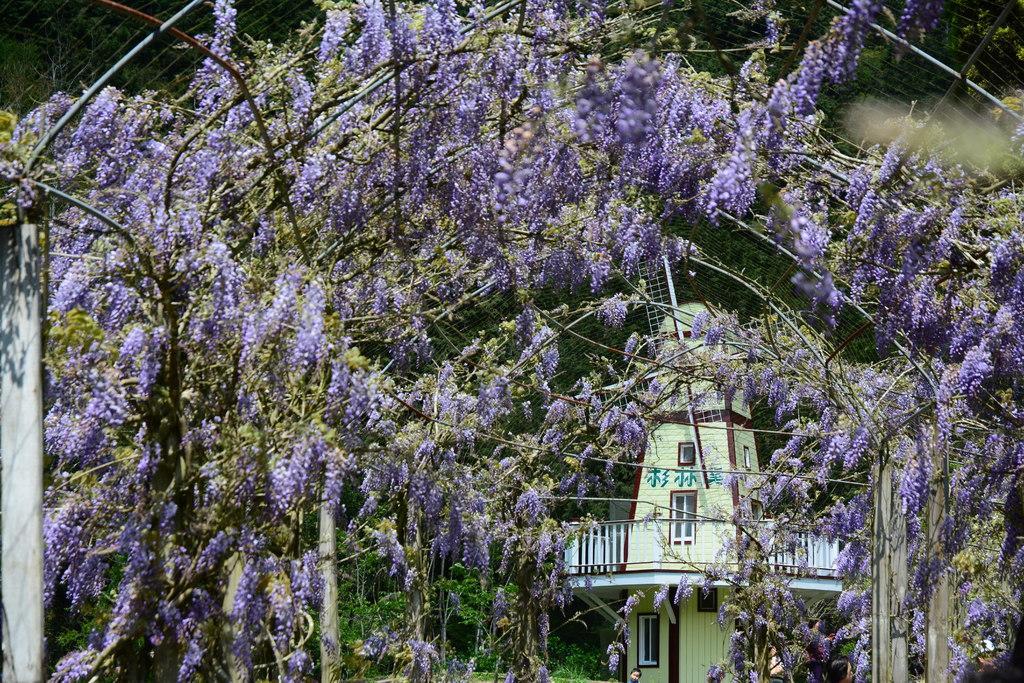How would you summarize this image in a sentence or two? In the image we can see there are flowers on the plants and behind there is a windmill building. 